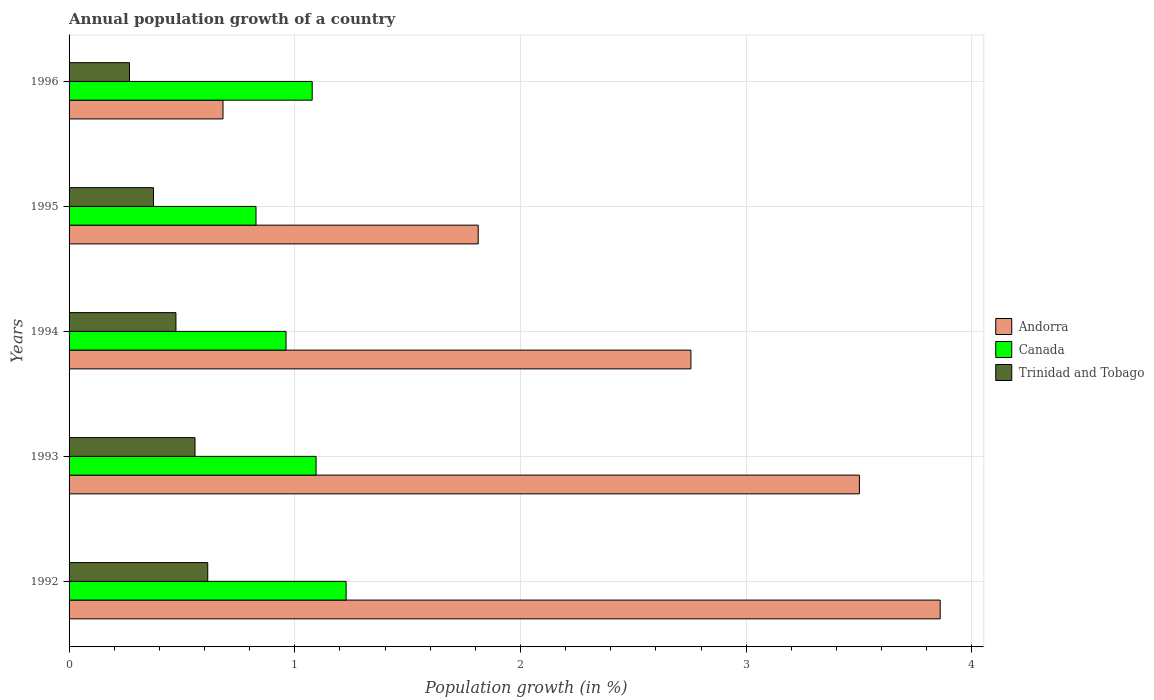How many different coloured bars are there?
Provide a short and direct response. 3. Are the number of bars per tick equal to the number of legend labels?
Your response must be concise. Yes. Are the number of bars on each tick of the Y-axis equal?
Ensure brevity in your answer.  Yes. What is the annual population growth in Andorra in 1992?
Provide a short and direct response. 3.86. Across all years, what is the maximum annual population growth in Trinidad and Tobago?
Provide a succinct answer. 0.61. Across all years, what is the minimum annual population growth in Canada?
Make the answer very short. 0.83. In which year was the annual population growth in Andorra maximum?
Provide a succinct answer. 1992. What is the total annual population growth in Trinidad and Tobago in the graph?
Ensure brevity in your answer.  2.29. What is the difference between the annual population growth in Andorra in 1992 and that in 1995?
Your response must be concise. 2.05. What is the difference between the annual population growth in Trinidad and Tobago in 1994 and the annual population growth in Canada in 1996?
Provide a short and direct response. -0.6. What is the average annual population growth in Trinidad and Tobago per year?
Your response must be concise. 0.46. In the year 1994, what is the difference between the annual population growth in Trinidad and Tobago and annual population growth in Andorra?
Keep it short and to the point. -2.28. In how many years, is the annual population growth in Canada greater than 0.8 %?
Provide a short and direct response. 5. What is the ratio of the annual population growth in Canada in 1992 to that in 1994?
Give a very brief answer. 1.28. Is the annual population growth in Andorra in 1993 less than that in 1995?
Keep it short and to the point. No. What is the difference between the highest and the second highest annual population growth in Canada?
Provide a succinct answer. 0.13. What is the difference between the highest and the lowest annual population growth in Canada?
Your response must be concise. 0.4. What does the 1st bar from the top in 1995 represents?
Your answer should be very brief. Trinidad and Tobago. What does the 1st bar from the bottom in 1995 represents?
Provide a succinct answer. Andorra. How many bars are there?
Offer a very short reply. 15. What is the difference between two consecutive major ticks on the X-axis?
Provide a short and direct response. 1. Are the values on the major ticks of X-axis written in scientific E-notation?
Give a very brief answer. No. Where does the legend appear in the graph?
Your answer should be compact. Center right. How many legend labels are there?
Your answer should be very brief. 3. How are the legend labels stacked?
Give a very brief answer. Vertical. What is the title of the graph?
Your answer should be very brief. Annual population growth of a country. Does "Hong Kong" appear as one of the legend labels in the graph?
Give a very brief answer. No. What is the label or title of the X-axis?
Provide a short and direct response. Population growth (in %). What is the Population growth (in %) of Andorra in 1992?
Offer a terse response. 3.86. What is the Population growth (in %) of Canada in 1992?
Offer a very short reply. 1.23. What is the Population growth (in %) in Trinidad and Tobago in 1992?
Ensure brevity in your answer.  0.61. What is the Population growth (in %) in Andorra in 1993?
Keep it short and to the point. 3.5. What is the Population growth (in %) in Canada in 1993?
Provide a short and direct response. 1.09. What is the Population growth (in %) in Trinidad and Tobago in 1993?
Offer a very short reply. 0.56. What is the Population growth (in %) in Andorra in 1994?
Keep it short and to the point. 2.76. What is the Population growth (in %) in Canada in 1994?
Provide a succinct answer. 0.96. What is the Population growth (in %) in Trinidad and Tobago in 1994?
Your response must be concise. 0.47. What is the Population growth (in %) in Andorra in 1995?
Give a very brief answer. 1.81. What is the Population growth (in %) in Canada in 1995?
Provide a succinct answer. 0.83. What is the Population growth (in %) in Trinidad and Tobago in 1995?
Give a very brief answer. 0.37. What is the Population growth (in %) of Andorra in 1996?
Ensure brevity in your answer.  0.68. What is the Population growth (in %) of Canada in 1996?
Your answer should be very brief. 1.08. What is the Population growth (in %) in Trinidad and Tobago in 1996?
Keep it short and to the point. 0.27. Across all years, what is the maximum Population growth (in %) of Andorra?
Provide a short and direct response. 3.86. Across all years, what is the maximum Population growth (in %) in Canada?
Ensure brevity in your answer.  1.23. Across all years, what is the maximum Population growth (in %) of Trinidad and Tobago?
Offer a terse response. 0.61. Across all years, what is the minimum Population growth (in %) of Andorra?
Ensure brevity in your answer.  0.68. Across all years, what is the minimum Population growth (in %) of Canada?
Provide a short and direct response. 0.83. Across all years, what is the minimum Population growth (in %) in Trinidad and Tobago?
Your response must be concise. 0.27. What is the total Population growth (in %) in Andorra in the graph?
Offer a very short reply. 12.61. What is the total Population growth (in %) in Canada in the graph?
Keep it short and to the point. 5.19. What is the total Population growth (in %) in Trinidad and Tobago in the graph?
Provide a short and direct response. 2.29. What is the difference between the Population growth (in %) in Andorra in 1992 and that in 1993?
Ensure brevity in your answer.  0.36. What is the difference between the Population growth (in %) of Canada in 1992 and that in 1993?
Ensure brevity in your answer.  0.13. What is the difference between the Population growth (in %) in Trinidad and Tobago in 1992 and that in 1993?
Offer a terse response. 0.06. What is the difference between the Population growth (in %) in Andorra in 1992 and that in 1994?
Ensure brevity in your answer.  1.1. What is the difference between the Population growth (in %) in Canada in 1992 and that in 1994?
Give a very brief answer. 0.27. What is the difference between the Population growth (in %) of Trinidad and Tobago in 1992 and that in 1994?
Give a very brief answer. 0.14. What is the difference between the Population growth (in %) of Andorra in 1992 and that in 1995?
Keep it short and to the point. 2.05. What is the difference between the Population growth (in %) in Canada in 1992 and that in 1995?
Provide a short and direct response. 0.4. What is the difference between the Population growth (in %) of Trinidad and Tobago in 1992 and that in 1995?
Give a very brief answer. 0.24. What is the difference between the Population growth (in %) of Andorra in 1992 and that in 1996?
Offer a very short reply. 3.18. What is the difference between the Population growth (in %) of Canada in 1992 and that in 1996?
Your answer should be very brief. 0.15. What is the difference between the Population growth (in %) in Trinidad and Tobago in 1992 and that in 1996?
Give a very brief answer. 0.35. What is the difference between the Population growth (in %) in Andorra in 1993 and that in 1994?
Keep it short and to the point. 0.75. What is the difference between the Population growth (in %) in Canada in 1993 and that in 1994?
Offer a very short reply. 0.13. What is the difference between the Population growth (in %) of Trinidad and Tobago in 1993 and that in 1994?
Make the answer very short. 0.08. What is the difference between the Population growth (in %) in Andorra in 1993 and that in 1995?
Ensure brevity in your answer.  1.69. What is the difference between the Population growth (in %) of Canada in 1993 and that in 1995?
Provide a short and direct response. 0.27. What is the difference between the Population growth (in %) of Trinidad and Tobago in 1993 and that in 1995?
Give a very brief answer. 0.18. What is the difference between the Population growth (in %) in Andorra in 1993 and that in 1996?
Your answer should be very brief. 2.82. What is the difference between the Population growth (in %) in Canada in 1993 and that in 1996?
Keep it short and to the point. 0.02. What is the difference between the Population growth (in %) in Trinidad and Tobago in 1993 and that in 1996?
Provide a succinct answer. 0.29. What is the difference between the Population growth (in %) of Andorra in 1994 and that in 1995?
Provide a succinct answer. 0.94. What is the difference between the Population growth (in %) in Canada in 1994 and that in 1995?
Provide a short and direct response. 0.13. What is the difference between the Population growth (in %) of Trinidad and Tobago in 1994 and that in 1995?
Make the answer very short. 0.1. What is the difference between the Population growth (in %) of Andorra in 1994 and that in 1996?
Offer a very short reply. 2.07. What is the difference between the Population growth (in %) of Canada in 1994 and that in 1996?
Provide a succinct answer. -0.12. What is the difference between the Population growth (in %) in Trinidad and Tobago in 1994 and that in 1996?
Your answer should be very brief. 0.21. What is the difference between the Population growth (in %) in Andorra in 1995 and that in 1996?
Your answer should be compact. 1.13. What is the difference between the Population growth (in %) in Canada in 1995 and that in 1996?
Offer a very short reply. -0.25. What is the difference between the Population growth (in %) in Trinidad and Tobago in 1995 and that in 1996?
Provide a short and direct response. 0.11. What is the difference between the Population growth (in %) of Andorra in 1992 and the Population growth (in %) of Canada in 1993?
Your answer should be very brief. 2.77. What is the difference between the Population growth (in %) of Andorra in 1992 and the Population growth (in %) of Trinidad and Tobago in 1993?
Provide a succinct answer. 3.3. What is the difference between the Population growth (in %) of Canada in 1992 and the Population growth (in %) of Trinidad and Tobago in 1993?
Offer a terse response. 0.67. What is the difference between the Population growth (in %) of Andorra in 1992 and the Population growth (in %) of Canada in 1994?
Provide a short and direct response. 2.9. What is the difference between the Population growth (in %) of Andorra in 1992 and the Population growth (in %) of Trinidad and Tobago in 1994?
Your answer should be compact. 3.39. What is the difference between the Population growth (in %) in Canada in 1992 and the Population growth (in %) in Trinidad and Tobago in 1994?
Offer a terse response. 0.75. What is the difference between the Population growth (in %) in Andorra in 1992 and the Population growth (in %) in Canada in 1995?
Give a very brief answer. 3.03. What is the difference between the Population growth (in %) in Andorra in 1992 and the Population growth (in %) in Trinidad and Tobago in 1995?
Provide a short and direct response. 3.49. What is the difference between the Population growth (in %) of Canada in 1992 and the Population growth (in %) of Trinidad and Tobago in 1995?
Offer a terse response. 0.85. What is the difference between the Population growth (in %) in Andorra in 1992 and the Population growth (in %) in Canada in 1996?
Keep it short and to the point. 2.78. What is the difference between the Population growth (in %) in Andorra in 1992 and the Population growth (in %) in Trinidad and Tobago in 1996?
Ensure brevity in your answer.  3.59. What is the difference between the Population growth (in %) of Canada in 1992 and the Population growth (in %) of Trinidad and Tobago in 1996?
Offer a terse response. 0.96. What is the difference between the Population growth (in %) of Andorra in 1993 and the Population growth (in %) of Canada in 1994?
Provide a succinct answer. 2.54. What is the difference between the Population growth (in %) of Andorra in 1993 and the Population growth (in %) of Trinidad and Tobago in 1994?
Your answer should be very brief. 3.03. What is the difference between the Population growth (in %) of Canada in 1993 and the Population growth (in %) of Trinidad and Tobago in 1994?
Ensure brevity in your answer.  0.62. What is the difference between the Population growth (in %) in Andorra in 1993 and the Population growth (in %) in Canada in 1995?
Your response must be concise. 2.67. What is the difference between the Population growth (in %) of Andorra in 1993 and the Population growth (in %) of Trinidad and Tobago in 1995?
Keep it short and to the point. 3.13. What is the difference between the Population growth (in %) of Canada in 1993 and the Population growth (in %) of Trinidad and Tobago in 1995?
Provide a short and direct response. 0.72. What is the difference between the Population growth (in %) in Andorra in 1993 and the Population growth (in %) in Canada in 1996?
Your answer should be very brief. 2.42. What is the difference between the Population growth (in %) of Andorra in 1993 and the Population growth (in %) of Trinidad and Tobago in 1996?
Offer a very short reply. 3.23. What is the difference between the Population growth (in %) in Canada in 1993 and the Population growth (in %) in Trinidad and Tobago in 1996?
Your answer should be very brief. 0.83. What is the difference between the Population growth (in %) in Andorra in 1994 and the Population growth (in %) in Canada in 1995?
Your response must be concise. 1.93. What is the difference between the Population growth (in %) in Andorra in 1994 and the Population growth (in %) in Trinidad and Tobago in 1995?
Give a very brief answer. 2.38. What is the difference between the Population growth (in %) in Canada in 1994 and the Population growth (in %) in Trinidad and Tobago in 1995?
Your answer should be very brief. 0.59. What is the difference between the Population growth (in %) of Andorra in 1994 and the Population growth (in %) of Canada in 1996?
Your response must be concise. 1.68. What is the difference between the Population growth (in %) of Andorra in 1994 and the Population growth (in %) of Trinidad and Tobago in 1996?
Provide a short and direct response. 2.49. What is the difference between the Population growth (in %) in Canada in 1994 and the Population growth (in %) in Trinidad and Tobago in 1996?
Provide a short and direct response. 0.69. What is the difference between the Population growth (in %) in Andorra in 1995 and the Population growth (in %) in Canada in 1996?
Ensure brevity in your answer.  0.74. What is the difference between the Population growth (in %) in Andorra in 1995 and the Population growth (in %) in Trinidad and Tobago in 1996?
Offer a terse response. 1.54. What is the difference between the Population growth (in %) in Canada in 1995 and the Population growth (in %) in Trinidad and Tobago in 1996?
Give a very brief answer. 0.56. What is the average Population growth (in %) of Andorra per year?
Offer a terse response. 2.52. What is the average Population growth (in %) of Canada per year?
Your answer should be compact. 1.04. What is the average Population growth (in %) in Trinidad and Tobago per year?
Make the answer very short. 0.46. In the year 1992, what is the difference between the Population growth (in %) in Andorra and Population growth (in %) in Canada?
Provide a short and direct response. 2.63. In the year 1992, what is the difference between the Population growth (in %) of Andorra and Population growth (in %) of Trinidad and Tobago?
Ensure brevity in your answer.  3.24. In the year 1992, what is the difference between the Population growth (in %) of Canada and Population growth (in %) of Trinidad and Tobago?
Offer a terse response. 0.61. In the year 1993, what is the difference between the Population growth (in %) of Andorra and Population growth (in %) of Canada?
Your answer should be very brief. 2.41. In the year 1993, what is the difference between the Population growth (in %) of Andorra and Population growth (in %) of Trinidad and Tobago?
Your response must be concise. 2.94. In the year 1993, what is the difference between the Population growth (in %) of Canada and Population growth (in %) of Trinidad and Tobago?
Your response must be concise. 0.54. In the year 1994, what is the difference between the Population growth (in %) in Andorra and Population growth (in %) in Canada?
Provide a short and direct response. 1.79. In the year 1994, what is the difference between the Population growth (in %) of Andorra and Population growth (in %) of Trinidad and Tobago?
Offer a very short reply. 2.28. In the year 1994, what is the difference between the Population growth (in %) in Canada and Population growth (in %) in Trinidad and Tobago?
Offer a terse response. 0.49. In the year 1995, what is the difference between the Population growth (in %) in Andorra and Population growth (in %) in Canada?
Make the answer very short. 0.98. In the year 1995, what is the difference between the Population growth (in %) of Andorra and Population growth (in %) of Trinidad and Tobago?
Your answer should be compact. 1.44. In the year 1995, what is the difference between the Population growth (in %) in Canada and Population growth (in %) in Trinidad and Tobago?
Provide a succinct answer. 0.45. In the year 1996, what is the difference between the Population growth (in %) in Andorra and Population growth (in %) in Canada?
Your answer should be very brief. -0.4. In the year 1996, what is the difference between the Population growth (in %) in Andorra and Population growth (in %) in Trinidad and Tobago?
Your answer should be very brief. 0.41. In the year 1996, what is the difference between the Population growth (in %) in Canada and Population growth (in %) in Trinidad and Tobago?
Your response must be concise. 0.81. What is the ratio of the Population growth (in %) of Andorra in 1992 to that in 1993?
Offer a very short reply. 1.1. What is the ratio of the Population growth (in %) in Canada in 1992 to that in 1993?
Your response must be concise. 1.12. What is the ratio of the Population growth (in %) in Trinidad and Tobago in 1992 to that in 1993?
Your answer should be compact. 1.1. What is the ratio of the Population growth (in %) in Andorra in 1992 to that in 1994?
Your answer should be compact. 1.4. What is the ratio of the Population growth (in %) of Canada in 1992 to that in 1994?
Your answer should be very brief. 1.28. What is the ratio of the Population growth (in %) of Trinidad and Tobago in 1992 to that in 1994?
Your answer should be very brief. 1.3. What is the ratio of the Population growth (in %) in Andorra in 1992 to that in 1995?
Offer a terse response. 2.13. What is the ratio of the Population growth (in %) of Canada in 1992 to that in 1995?
Your response must be concise. 1.48. What is the ratio of the Population growth (in %) in Trinidad and Tobago in 1992 to that in 1995?
Ensure brevity in your answer.  1.64. What is the ratio of the Population growth (in %) of Andorra in 1992 to that in 1996?
Make the answer very short. 5.66. What is the ratio of the Population growth (in %) of Canada in 1992 to that in 1996?
Keep it short and to the point. 1.14. What is the ratio of the Population growth (in %) in Trinidad and Tobago in 1992 to that in 1996?
Your answer should be compact. 2.3. What is the ratio of the Population growth (in %) in Andorra in 1993 to that in 1994?
Your answer should be compact. 1.27. What is the ratio of the Population growth (in %) of Canada in 1993 to that in 1994?
Provide a short and direct response. 1.14. What is the ratio of the Population growth (in %) in Trinidad and Tobago in 1993 to that in 1994?
Give a very brief answer. 1.18. What is the ratio of the Population growth (in %) in Andorra in 1993 to that in 1995?
Offer a terse response. 1.93. What is the ratio of the Population growth (in %) of Canada in 1993 to that in 1995?
Your response must be concise. 1.32. What is the ratio of the Population growth (in %) in Trinidad and Tobago in 1993 to that in 1995?
Provide a short and direct response. 1.49. What is the ratio of the Population growth (in %) of Andorra in 1993 to that in 1996?
Keep it short and to the point. 5.13. What is the ratio of the Population growth (in %) in Canada in 1993 to that in 1996?
Provide a short and direct response. 1.02. What is the ratio of the Population growth (in %) in Trinidad and Tobago in 1993 to that in 1996?
Give a very brief answer. 2.08. What is the ratio of the Population growth (in %) of Andorra in 1994 to that in 1995?
Offer a terse response. 1.52. What is the ratio of the Population growth (in %) in Canada in 1994 to that in 1995?
Ensure brevity in your answer.  1.16. What is the ratio of the Population growth (in %) in Trinidad and Tobago in 1994 to that in 1995?
Ensure brevity in your answer.  1.27. What is the ratio of the Population growth (in %) in Andorra in 1994 to that in 1996?
Offer a terse response. 4.04. What is the ratio of the Population growth (in %) in Canada in 1994 to that in 1996?
Provide a short and direct response. 0.89. What is the ratio of the Population growth (in %) in Trinidad and Tobago in 1994 to that in 1996?
Your answer should be very brief. 1.77. What is the ratio of the Population growth (in %) of Andorra in 1995 to that in 1996?
Your answer should be compact. 2.66. What is the ratio of the Population growth (in %) of Canada in 1995 to that in 1996?
Make the answer very short. 0.77. What is the ratio of the Population growth (in %) in Trinidad and Tobago in 1995 to that in 1996?
Make the answer very short. 1.4. What is the difference between the highest and the second highest Population growth (in %) in Andorra?
Your answer should be compact. 0.36. What is the difference between the highest and the second highest Population growth (in %) in Canada?
Provide a short and direct response. 0.13. What is the difference between the highest and the second highest Population growth (in %) in Trinidad and Tobago?
Your response must be concise. 0.06. What is the difference between the highest and the lowest Population growth (in %) in Andorra?
Offer a terse response. 3.18. What is the difference between the highest and the lowest Population growth (in %) in Canada?
Offer a terse response. 0.4. What is the difference between the highest and the lowest Population growth (in %) in Trinidad and Tobago?
Provide a short and direct response. 0.35. 